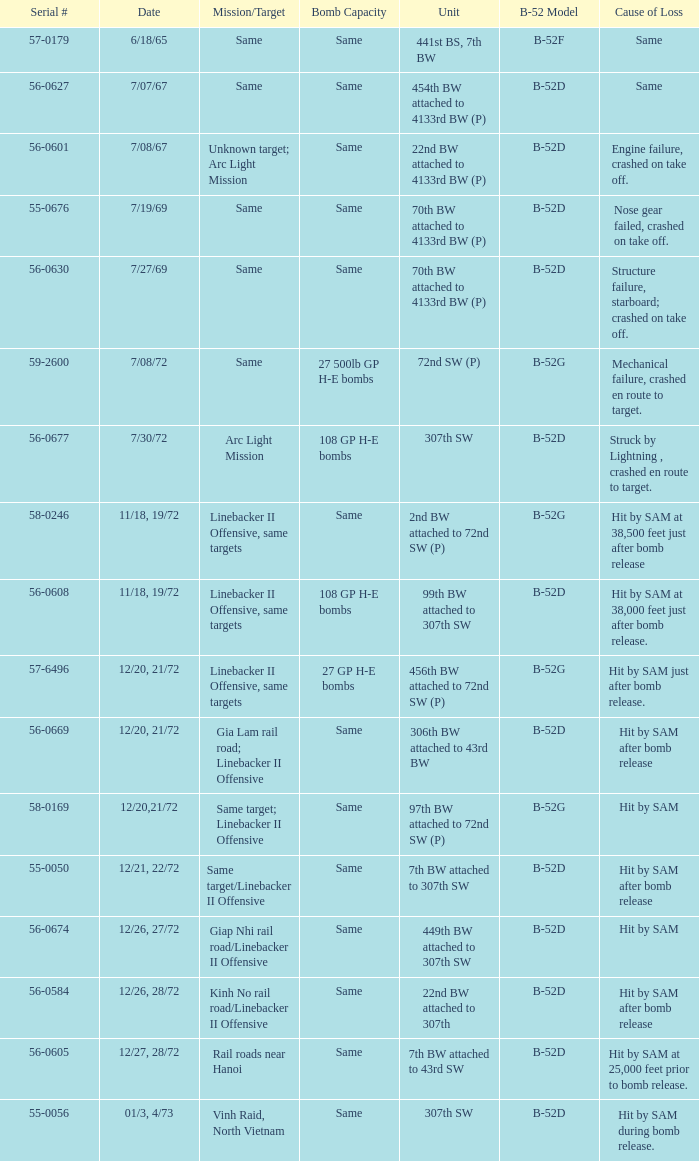When 7th bw attached to 43rd sw is the unit what is the b-52 model? B-52D. 